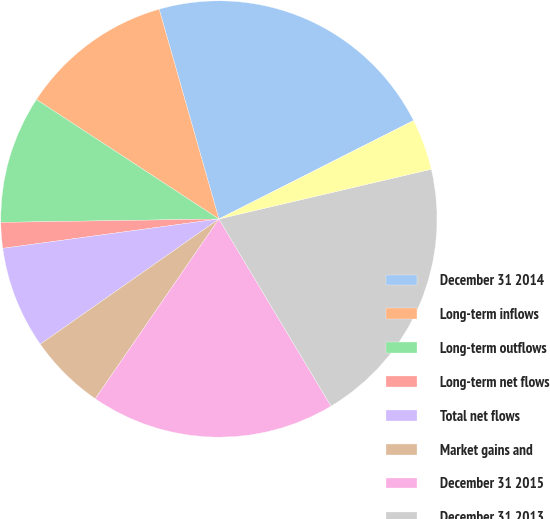Convert chart to OTSL. <chart><loc_0><loc_0><loc_500><loc_500><pie_chart><fcel>December 31 2014<fcel>Long-term inflows<fcel>Long-term outflows<fcel>Long-term net flows<fcel>Total net flows<fcel>Market gains and<fcel>December 31 2015<fcel>December 31 2013<fcel>Net flows in institutional<fcel>Foreign currency translation<nl><fcel>21.96%<fcel>11.36%<fcel>9.47%<fcel>1.9%<fcel>7.58%<fcel>5.68%<fcel>18.18%<fcel>20.07%<fcel>3.79%<fcel>0.0%<nl></chart> 